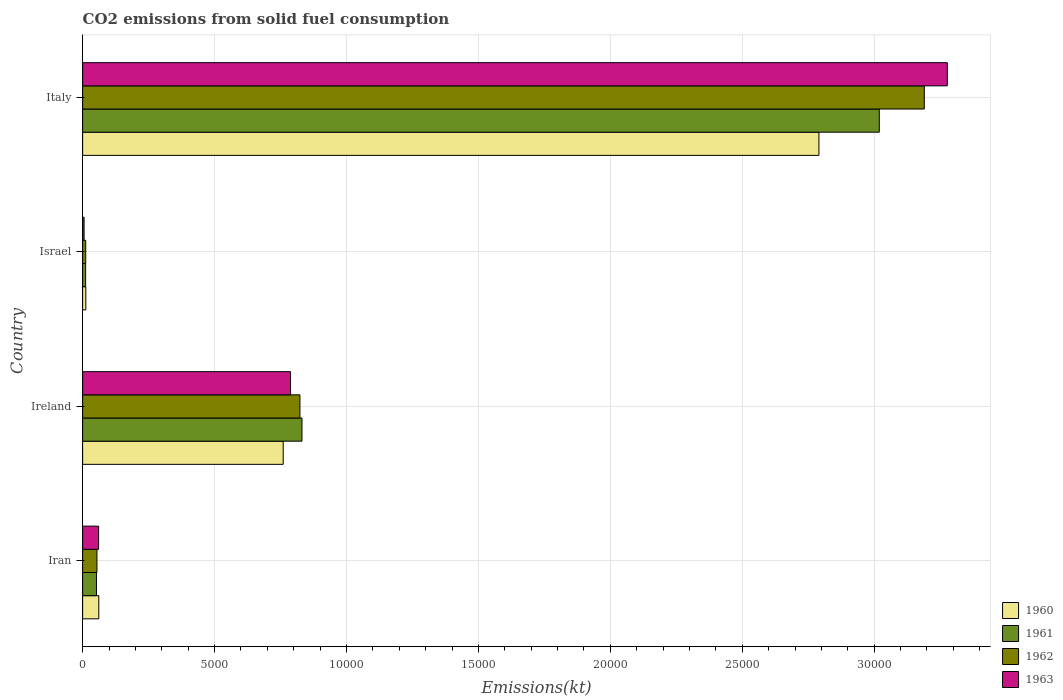How many different coloured bars are there?
Offer a very short reply. 4. Are the number of bars on each tick of the Y-axis equal?
Ensure brevity in your answer.  Yes. What is the label of the 2nd group of bars from the top?
Keep it short and to the point. Israel. In how many cases, is the number of bars for a given country not equal to the number of legend labels?
Offer a terse response. 0. What is the amount of CO2 emitted in 1962 in Ireland?
Provide a succinct answer. 8236.08. Across all countries, what is the maximum amount of CO2 emitted in 1962?
Offer a very short reply. 3.19e+04. Across all countries, what is the minimum amount of CO2 emitted in 1960?
Provide a short and direct response. 121.01. What is the total amount of CO2 emitted in 1961 in the graph?
Your answer should be compact. 3.91e+04. What is the difference between the amount of CO2 emitted in 1961 in Iran and that in Israel?
Make the answer very short. 410.7. What is the difference between the amount of CO2 emitted in 1963 in Ireland and the amount of CO2 emitted in 1962 in Israel?
Your answer should be compact. 7763.04. What is the average amount of CO2 emitted in 1963 per country?
Your response must be concise. 1.03e+04. What is the difference between the amount of CO2 emitted in 1963 and amount of CO2 emitted in 1962 in Ireland?
Ensure brevity in your answer.  -355.7. In how many countries, is the amount of CO2 emitted in 1960 greater than 29000 kt?
Provide a short and direct response. 0. What is the ratio of the amount of CO2 emitted in 1960 in Israel to that in Italy?
Offer a terse response. 0. Is the amount of CO2 emitted in 1962 in Iran less than that in Ireland?
Ensure brevity in your answer.  Yes. What is the difference between the highest and the second highest amount of CO2 emitted in 1963?
Keep it short and to the point. 2.49e+04. What is the difference between the highest and the lowest amount of CO2 emitted in 1961?
Offer a terse response. 3.01e+04. What does the 2nd bar from the bottom in Ireland represents?
Provide a succinct answer. 1961. Is it the case that in every country, the sum of the amount of CO2 emitted in 1960 and amount of CO2 emitted in 1961 is greater than the amount of CO2 emitted in 1962?
Your answer should be compact. Yes. How many bars are there?
Provide a succinct answer. 16. Are all the bars in the graph horizontal?
Offer a terse response. Yes. What is the difference between two consecutive major ticks on the X-axis?
Provide a succinct answer. 5000. Are the values on the major ticks of X-axis written in scientific E-notation?
Provide a succinct answer. No. Does the graph contain any zero values?
Your answer should be compact. No. Does the graph contain grids?
Your answer should be compact. Yes. How many legend labels are there?
Your response must be concise. 4. What is the title of the graph?
Make the answer very short. CO2 emissions from solid fuel consumption. What is the label or title of the X-axis?
Your answer should be very brief. Emissions(kt). What is the Emissions(kt) of 1960 in Iran?
Provide a short and direct response. 612.39. What is the Emissions(kt) in 1961 in Iran?
Your response must be concise. 524.38. What is the Emissions(kt) of 1962 in Iran?
Your answer should be very brief. 542.72. What is the Emissions(kt) in 1963 in Iran?
Ensure brevity in your answer.  605.05. What is the Emissions(kt) in 1960 in Ireland?
Your response must be concise. 7601.69. What is the Emissions(kt) in 1961 in Ireland?
Your response must be concise. 8313.09. What is the Emissions(kt) of 1962 in Ireland?
Make the answer very short. 8236.08. What is the Emissions(kt) in 1963 in Ireland?
Make the answer very short. 7880.38. What is the Emissions(kt) in 1960 in Israel?
Your response must be concise. 121.01. What is the Emissions(kt) of 1961 in Israel?
Give a very brief answer. 113.68. What is the Emissions(kt) of 1962 in Israel?
Provide a short and direct response. 117.34. What is the Emissions(kt) of 1963 in Israel?
Provide a short and direct response. 55.01. What is the Emissions(kt) in 1960 in Italy?
Your response must be concise. 2.79e+04. What is the Emissions(kt) in 1961 in Italy?
Make the answer very short. 3.02e+04. What is the Emissions(kt) of 1962 in Italy?
Your answer should be compact. 3.19e+04. What is the Emissions(kt) in 1963 in Italy?
Keep it short and to the point. 3.28e+04. Across all countries, what is the maximum Emissions(kt) of 1960?
Your answer should be compact. 2.79e+04. Across all countries, what is the maximum Emissions(kt) in 1961?
Provide a succinct answer. 3.02e+04. Across all countries, what is the maximum Emissions(kt) in 1962?
Keep it short and to the point. 3.19e+04. Across all countries, what is the maximum Emissions(kt) in 1963?
Your answer should be very brief. 3.28e+04. Across all countries, what is the minimum Emissions(kt) of 1960?
Make the answer very short. 121.01. Across all countries, what is the minimum Emissions(kt) of 1961?
Make the answer very short. 113.68. Across all countries, what is the minimum Emissions(kt) in 1962?
Your answer should be very brief. 117.34. Across all countries, what is the minimum Emissions(kt) in 1963?
Give a very brief answer. 55.01. What is the total Emissions(kt) in 1960 in the graph?
Ensure brevity in your answer.  3.62e+04. What is the total Emissions(kt) of 1961 in the graph?
Your answer should be very brief. 3.91e+04. What is the total Emissions(kt) in 1962 in the graph?
Offer a terse response. 4.08e+04. What is the total Emissions(kt) in 1963 in the graph?
Your answer should be very brief. 4.13e+04. What is the difference between the Emissions(kt) in 1960 in Iran and that in Ireland?
Your answer should be very brief. -6989.3. What is the difference between the Emissions(kt) of 1961 in Iran and that in Ireland?
Offer a terse response. -7788.71. What is the difference between the Emissions(kt) in 1962 in Iran and that in Ireland?
Ensure brevity in your answer.  -7693.37. What is the difference between the Emissions(kt) of 1963 in Iran and that in Ireland?
Offer a terse response. -7275.33. What is the difference between the Emissions(kt) of 1960 in Iran and that in Israel?
Keep it short and to the point. 491.38. What is the difference between the Emissions(kt) in 1961 in Iran and that in Israel?
Ensure brevity in your answer.  410.7. What is the difference between the Emissions(kt) of 1962 in Iran and that in Israel?
Your answer should be compact. 425.37. What is the difference between the Emissions(kt) in 1963 in Iran and that in Israel?
Provide a short and direct response. 550.05. What is the difference between the Emissions(kt) of 1960 in Iran and that in Italy?
Your answer should be very brief. -2.73e+04. What is the difference between the Emissions(kt) in 1961 in Iran and that in Italy?
Your answer should be very brief. -2.97e+04. What is the difference between the Emissions(kt) of 1962 in Iran and that in Italy?
Give a very brief answer. -3.14e+04. What is the difference between the Emissions(kt) in 1963 in Iran and that in Italy?
Offer a terse response. -3.22e+04. What is the difference between the Emissions(kt) in 1960 in Ireland and that in Israel?
Offer a very short reply. 7480.68. What is the difference between the Emissions(kt) of 1961 in Ireland and that in Israel?
Make the answer very short. 8199.41. What is the difference between the Emissions(kt) in 1962 in Ireland and that in Israel?
Your answer should be very brief. 8118.74. What is the difference between the Emissions(kt) of 1963 in Ireland and that in Israel?
Give a very brief answer. 7825.38. What is the difference between the Emissions(kt) in 1960 in Ireland and that in Italy?
Give a very brief answer. -2.03e+04. What is the difference between the Emissions(kt) of 1961 in Ireland and that in Italy?
Provide a succinct answer. -2.19e+04. What is the difference between the Emissions(kt) in 1962 in Ireland and that in Italy?
Provide a short and direct response. -2.37e+04. What is the difference between the Emissions(kt) of 1963 in Ireland and that in Italy?
Provide a succinct answer. -2.49e+04. What is the difference between the Emissions(kt) in 1960 in Israel and that in Italy?
Offer a terse response. -2.78e+04. What is the difference between the Emissions(kt) in 1961 in Israel and that in Italy?
Make the answer very short. -3.01e+04. What is the difference between the Emissions(kt) in 1962 in Israel and that in Italy?
Offer a terse response. -3.18e+04. What is the difference between the Emissions(kt) of 1963 in Israel and that in Italy?
Offer a terse response. -3.27e+04. What is the difference between the Emissions(kt) in 1960 in Iran and the Emissions(kt) in 1961 in Ireland?
Your answer should be compact. -7700.7. What is the difference between the Emissions(kt) of 1960 in Iran and the Emissions(kt) of 1962 in Ireland?
Offer a terse response. -7623.69. What is the difference between the Emissions(kt) in 1960 in Iran and the Emissions(kt) in 1963 in Ireland?
Offer a very short reply. -7267.99. What is the difference between the Emissions(kt) of 1961 in Iran and the Emissions(kt) of 1962 in Ireland?
Your answer should be compact. -7711.7. What is the difference between the Emissions(kt) in 1961 in Iran and the Emissions(kt) in 1963 in Ireland?
Ensure brevity in your answer.  -7356. What is the difference between the Emissions(kt) of 1962 in Iran and the Emissions(kt) of 1963 in Ireland?
Offer a terse response. -7337.67. What is the difference between the Emissions(kt) in 1960 in Iran and the Emissions(kt) in 1961 in Israel?
Give a very brief answer. 498.71. What is the difference between the Emissions(kt) in 1960 in Iran and the Emissions(kt) in 1962 in Israel?
Provide a short and direct response. 495.05. What is the difference between the Emissions(kt) of 1960 in Iran and the Emissions(kt) of 1963 in Israel?
Make the answer very short. 557.38. What is the difference between the Emissions(kt) of 1961 in Iran and the Emissions(kt) of 1962 in Israel?
Ensure brevity in your answer.  407.04. What is the difference between the Emissions(kt) in 1961 in Iran and the Emissions(kt) in 1963 in Israel?
Ensure brevity in your answer.  469.38. What is the difference between the Emissions(kt) in 1962 in Iran and the Emissions(kt) in 1963 in Israel?
Make the answer very short. 487.71. What is the difference between the Emissions(kt) in 1960 in Iran and the Emissions(kt) in 1961 in Italy?
Ensure brevity in your answer.  -2.96e+04. What is the difference between the Emissions(kt) of 1960 in Iran and the Emissions(kt) of 1962 in Italy?
Make the answer very short. -3.13e+04. What is the difference between the Emissions(kt) in 1960 in Iran and the Emissions(kt) in 1963 in Italy?
Provide a succinct answer. -3.22e+04. What is the difference between the Emissions(kt) in 1961 in Iran and the Emissions(kt) in 1962 in Italy?
Your answer should be compact. -3.14e+04. What is the difference between the Emissions(kt) of 1961 in Iran and the Emissions(kt) of 1963 in Italy?
Provide a short and direct response. -3.22e+04. What is the difference between the Emissions(kt) of 1962 in Iran and the Emissions(kt) of 1963 in Italy?
Your response must be concise. -3.22e+04. What is the difference between the Emissions(kt) of 1960 in Ireland and the Emissions(kt) of 1961 in Israel?
Keep it short and to the point. 7488.01. What is the difference between the Emissions(kt) in 1960 in Ireland and the Emissions(kt) in 1962 in Israel?
Keep it short and to the point. 7484.35. What is the difference between the Emissions(kt) of 1960 in Ireland and the Emissions(kt) of 1963 in Israel?
Your response must be concise. 7546.69. What is the difference between the Emissions(kt) of 1961 in Ireland and the Emissions(kt) of 1962 in Israel?
Your answer should be compact. 8195.75. What is the difference between the Emissions(kt) in 1961 in Ireland and the Emissions(kt) in 1963 in Israel?
Make the answer very short. 8258.08. What is the difference between the Emissions(kt) of 1962 in Ireland and the Emissions(kt) of 1963 in Israel?
Offer a terse response. 8181.08. What is the difference between the Emissions(kt) in 1960 in Ireland and the Emissions(kt) in 1961 in Italy?
Keep it short and to the point. -2.26e+04. What is the difference between the Emissions(kt) in 1960 in Ireland and the Emissions(kt) in 1962 in Italy?
Your answer should be compact. -2.43e+04. What is the difference between the Emissions(kt) in 1960 in Ireland and the Emissions(kt) in 1963 in Italy?
Your answer should be compact. -2.52e+04. What is the difference between the Emissions(kt) in 1961 in Ireland and the Emissions(kt) in 1962 in Italy?
Offer a terse response. -2.36e+04. What is the difference between the Emissions(kt) in 1961 in Ireland and the Emissions(kt) in 1963 in Italy?
Provide a succinct answer. -2.45e+04. What is the difference between the Emissions(kt) of 1962 in Ireland and the Emissions(kt) of 1963 in Italy?
Ensure brevity in your answer.  -2.45e+04. What is the difference between the Emissions(kt) in 1960 in Israel and the Emissions(kt) in 1961 in Italy?
Your response must be concise. -3.01e+04. What is the difference between the Emissions(kt) of 1960 in Israel and the Emissions(kt) of 1962 in Italy?
Give a very brief answer. -3.18e+04. What is the difference between the Emissions(kt) of 1960 in Israel and the Emissions(kt) of 1963 in Italy?
Ensure brevity in your answer.  -3.27e+04. What is the difference between the Emissions(kt) in 1961 in Israel and the Emissions(kt) in 1962 in Italy?
Make the answer very short. -3.18e+04. What is the difference between the Emissions(kt) of 1961 in Israel and the Emissions(kt) of 1963 in Italy?
Your answer should be compact. -3.27e+04. What is the difference between the Emissions(kt) of 1962 in Israel and the Emissions(kt) of 1963 in Italy?
Make the answer very short. -3.27e+04. What is the average Emissions(kt) of 1960 per country?
Ensure brevity in your answer.  9060.24. What is the average Emissions(kt) in 1961 per country?
Ensure brevity in your answer.  9786.31. What is the average Emissions(kt) in 1962 per country?
Provide a succinct answer. 1.02e+04. What is the average Emissions(kt) in 1963 per country?
Give a very brief answer. 1.03e+04. What is the difference between the Emissions(kt) in 1960 and Emissions(kt) in 1961 in Iran?
Your answer should be very brief. 88.01. What is the difference between the Emissions(kt) in 1960 and Emissions(kt) in 1962 in Iran?
Make the answer very short. 69.67. What is the difference between the Emissions(kt) in 1960 and Emissions(kt) in 1963 in Iran?
Your answer should be compact. 7.33. What is the difference between the Emissions(kt) of 1961 and Emissions(kt) of 1962 in Iran?
Provide a succinct answer. -18.34. What is the difference between the Emissions(kt) in 1961 and Emissions(kt) in 1963 in Iran?
Give a very brief answer. -80.67. What is the difference between the Emissions(kt) of 1962 and Emissions(kt) of 1963 in Iran?
Your answer should be very brief. -62.34. What is the difference between the Emissions(kt) of 1960 and Emissions(kt) of 1961 in Ireland?
Ensure brevity in your answer.  -711.4. What is the difference between the Emissions(kt) in 1960 and Emissions(kt) in 1962 in Ireland?
Provide a succinct answer. -634.39. What is the difference between the Emissions(kt) of 1960 and Emissions(kt) of 1963 in Ireland?
Give a very brief answer. -278.69. What is the difference between the Emissions(kt) of 1961 and Emissions(kt) of 1962 in Ireland?
Your answer should be very brief. 77.01. What is the difference between the Emissions(kt) of 1961 and Emissions(kt) of 1963 in Ireland?
Keep it short and to the point. 432.71. What is the difference between the Emissions(kt) of 1962 and Emissions(kt) of 1963 in Ireland?
Provide a succinct answer. 355.7. What is the difference between the Emissions(kt) of 1960 and Emissions(kt) of 1961 in Israel?
Your answer should be compact. 7.33. What is the difference between the Emissions(kt) in 1960 and Emissions(kt) in 1962 in Israel?
Offer a very short reply. 3.67. What is the difference between the Emissions(kt) of 1960 and Emissions(kt) of 1963 in Israel?
Your response must be concise. 66.01. What is the difference between the Emissions(kt) of 1961 and Emissions(kt) of 1962 in Israel?
Make the answer very short. -3.67. What is the difference between the Emissions(kt) of 1961 and Emissions(kt) of 1963 in Israel?
Keep it short and to the point. 58.67. What is the difference between the Emissions(kt) in 1962 and Emissions(kt) in 1963 in Israel?
Give a very brief answer. 62.34. What is the difference between the Emissions(kt) in 1960 and Emissions(kt) in 1961 in Italy?
Make the answer very short. -2288.21. What is the difference between the Emissions(kt) of 1960 and Emissions(kt) of 1962 in Italy?
Offer a terse response. -3993.36. What is the difference between the Emissions(kt) of 1960 and Emissions(kt) of 1963 in Italy?
Ensure brevity in your answer.  -4866.11. What is the difference between the Emissions(kt) of 1961 and Emissions(kt) of 1962 in Italy?
Make the answer very short. -1705.15. What is the difference between the Emissions(kt) in 1961 and Emissions(kt) in 1963 in Italy?
Make the answer very short. -2577.9. What is the difference between the Emissions(kt) of 1962 and Emissions(kt) of 1963 in Italy?
Your answer should be compact. -872.75. What is the ratio of the Emissions(kt) of 1960 in Iran to that in Ireland?
Offer a terse response. 0.08. What is the ratio of the Emissions(kt) of 1961 in Iran to that in Ireland?
Ensure brevity in your answer.  0.06. What is the ratio of the Emissions(kt) in 1962 in Iran to that in Ireland?
Offer a very short reply. 0.07. What is the ratio of the Emissions(kt) of 1963 in Iran to that in Ireland?
Ensure brevity in your answer.  0.08. What is the ratio of the Emissions(kt) of 1960 in Iran to that in Israel?
Offer a very short reply. 5.06. What is the ratio of the Emissions(kt) of 1961 in Iran to that in Israel?
Your answer should be very brief. 4.61. What is the ratio of the Emissions(kt) in 1962 in Iran to that in Israel?
Provide a short and direct response. 4.62. What is the ratio of the Emissions(kt) in 1963 in Iran to that in Israel?
Provide a short and direct response. 11. What is the ratio of the Emissions(kt) of 1960 in Iran to that in Italy?
Keep it short and to the point. 0.02. What is the ratio of the Emissions(kt) in 1961 in Iran to that in Italy?
Keep it short and to the point. 0.02. What is the ratio of the Emissions(kt) in 1962 in Iran to that in Italy?
Provide a succinct answer. 0.02. What is the ratio of the Emissions(kt) in 1963 in Iran to that in Italy?
Keep it short and to the point. 0.02. What is the ratio of the Emissions(kt) in 1960 in Ireland to that in Israel?
Provide a succinct answer. 62.82. What is the ratio of the Emissions(kt) of 1961 in Ireland to that in Israel?
Your answer should be compact. 73.13. What is the ratio of the Emissions(kt) in 1962 in Ireland to that in Israel?
Your answer should be very brief. 70.19. What is the ratio of the Emissions(kt) of 1963 in Ireland to that in Israel?
Your answer should be compact. 143.27. What is the ratio of the Emissions(kt) of 1960 in Ireland to that in Italy?
Provide a succinct answer. 0.27. What is the ratio of the Emissions(kt) of 1961 in Ireland to that in Italy?
Keep it short and to the point. 0.28. What is the ratio of the Emissions(kt) in 1962 in Ireland to that in Italy?
Provide a short and direct response. 0.26. What is the ratio of the Emissions(kt) in 1963 in Ireland to that in Italy?
Give a very brief answer. 0.24. What is the ratio of the Emissions(kt) in 1960 in Israel to that in Italy?
Your response must be concise. 0. What is the ratio of the Emissions(kt) in 1961 in Israel to that in Italy?
Offer a very short reply. 0. What is the ratio of the Emissions(kt) of 1962 in Israel to that in Italy?
Your answer should be compact. 0. What is the ratio of the Emissions(kt) of 1963 in Israel to that in Italy?
Offer a terse response. 0. What is the difference between the highest and the second highest Emissions(kt) of 1960?
Offer a very short reply. 2.03e+04. What is the difference between the highest and the second highest Emissions(kt) in 1961?
Keep it short and to the point. 2.19e+04. What is the difference between the highest and the second highest Emissions(kt) of 1962?
Offer a terse response. 2.37e+04. What is the difference between the highest and the second highest Emissions(kt) in 1963?
Offer a very short reply. 2.49e+04. What is the difference between the highest and the lowest Emissions(kt) of 1960?
Ensure brevity in your answer.  2.78e+04. What is the difference between the highest and the lowest Emissions(kt) in 1961?
Your answer should be very brief. 3.01e+04. What is the difference between the highest and the lowest Emissions(kt) in 1962?
Your answer should be very brief. 3.18e+04. What is the difference between the highest and the lowest Emissions(kt) in 1963?
Provide a short and direct response. 3.27e+04. 